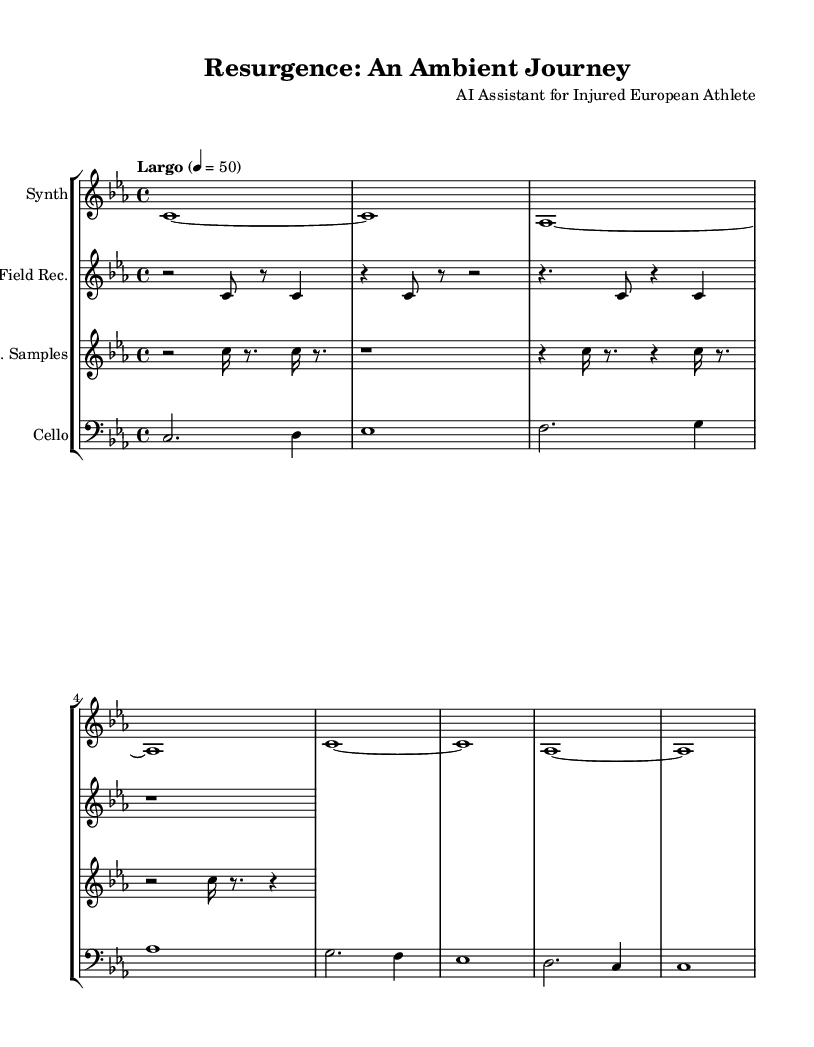What is the key signature of this music? The key signature is C minor, indicated by the presence of three flats (B♭, E♭, and A♭).
Answer: C minor What is the time signature of this music? The time signature is 4/4, shown at the beginning of the sheet music, meaning there are four beats per measure.
Answer: 4/4 What is the tempo marking for the piece? The tempo marking is "Largo," which indicates a slow tempo, and the metronome indication is 50 beats per minute.
Answer: Largo How many staves are present in the score? There are four staves present in the score, each representing different instruments: Synth, Field Recording, Industrial Samples, and Cello.
Answer: Four Which part uses field recordings? The part that uses field recordings is labeled "Field Rec." in the score, showcasing a unique blend of natural sound patterns.
Answer: Field Rec What type of ambiance does the music aim to reflect? The music aims to reflect a recovery journey through ambient soundscapes, blending natural sounds with industrial noise as expressed by the varying instruments.
Answer: Recovery journey What is the use of industrial samples in this music? Industrial samples are used as a contrasting element in the piece, highlighted by irregular rhythms and tones, to evoke the complexity of the recovery process.
Answer: To evoke complexity 